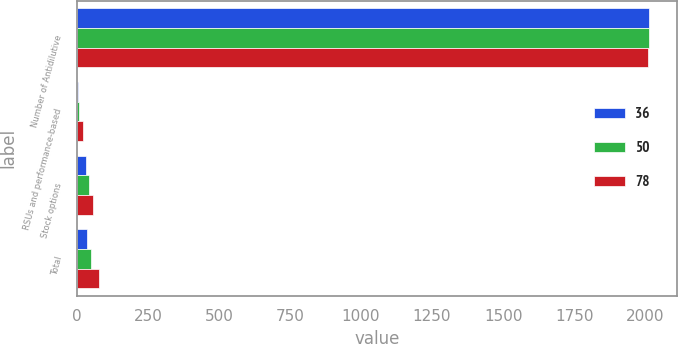Convert chart. <chart><loc_0><loc_0><loc_500><loc_500><stacked_bar_chart><ecel><fcel>Number of Antidilutive<fcel>RSUs and performance-based<fcel>Stock options<fcel>Total<nl><fcel>36<fcel>2013<fcel>3<fcel>33<fcel>36<nl><fcel>50<fcel>2012<fcel>8<fcel>42<fcel>50<nl><fcel>78<fcel>2011<fcel>21<fcel>57<fcel>78<nl></chart> 